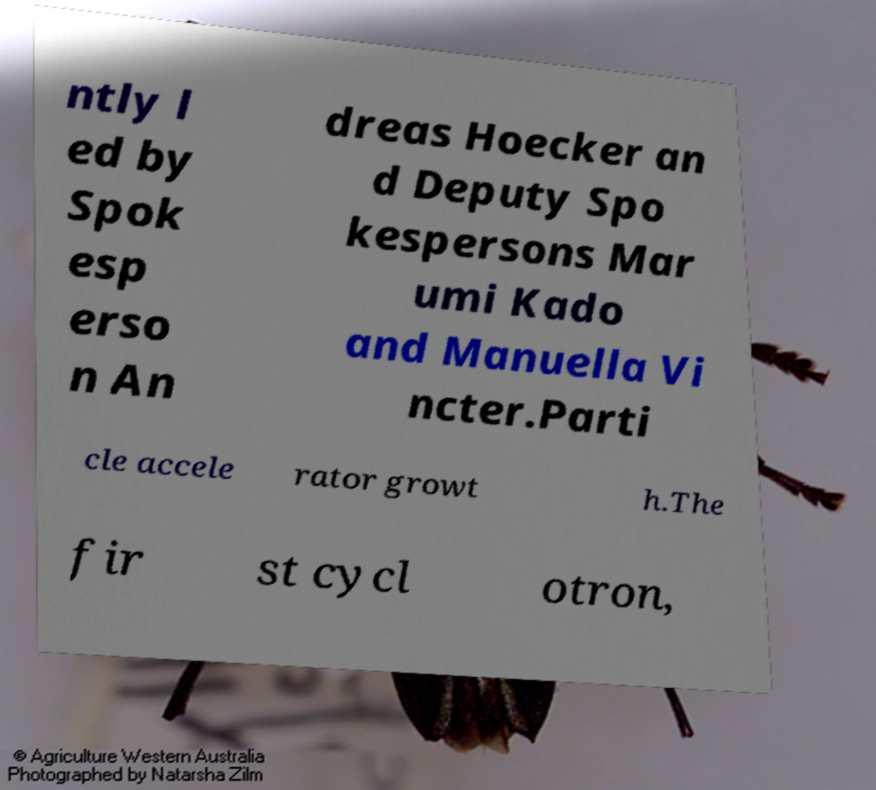For documentation purposes, I need the text within this image transcribed. Could you provide that? ntly l ed by Spok esp erso n An dreas Hoecker an d Deputy Spo kespersons Mar umi Kado and Manuella Vi ncter.Parti cle accele rator growt h.The fir st cycl otron, 